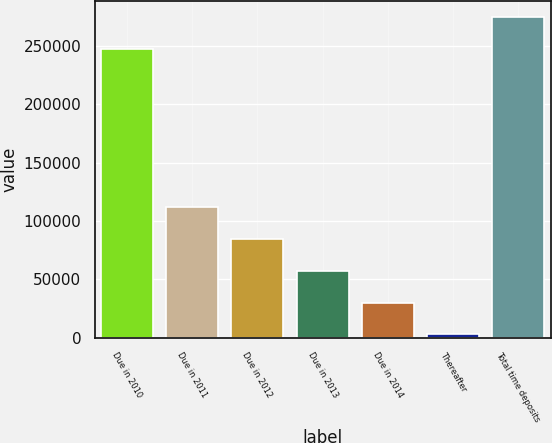Convert chart. <chart><loc_0><loc_0><loc_500><loc_500><bar_chart><fcel>Due in 2010<fcel>Due in 2011<fcel>Due in 2012<fcel>Due in 2013<fcel>Due in 2014<fcel>Thereafter<fcel>Total time deposits<nl><fcel>247238<fcel>111477<fcel>84263.6<fcel>57050.4<fcel>29837.2<fcel>2624<fcel>274756<nl></chart> 